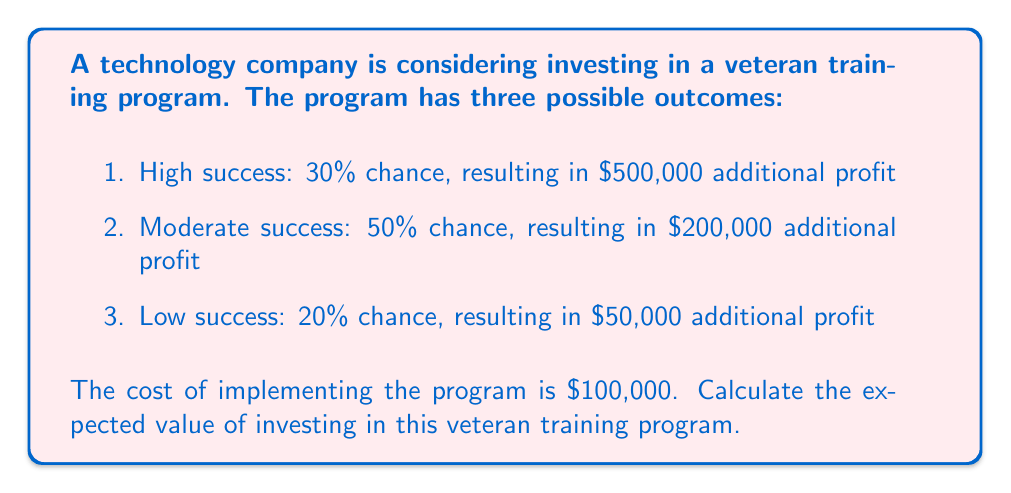Teach me how to tackle this problem. To calculate the expected value of investing in the veteran training program, we need to follow these steps:

1. Calculate the expected value of the program's outcomes:
   a. High success: $EV_1 = 0.30 \times \$500,000 = \$150,000$
   b. Moderate success: $EV_2 = 0.50 \times \$200,000 = \$100,000$
   c. Low success: $EV_3 = 0.20 \times \$50,000 = \$10,000$

2. Sum up the expected values of all outcomes:
   $$EV_{total} = EV_1 + EV_2 + EV_3 = \$150,000 + \$100,000 + \$10,000 = \$260,000$$

3. Subtract the cost of implementing the program:
   $$EV_{net} = EV_{total} - \text{Cost} = \$260,000 - \$100,000 = \$160,000$$

The expected value of investing in the veteran training program is the net expected value after subtracting the implementation cost.
Answer: $160,000 